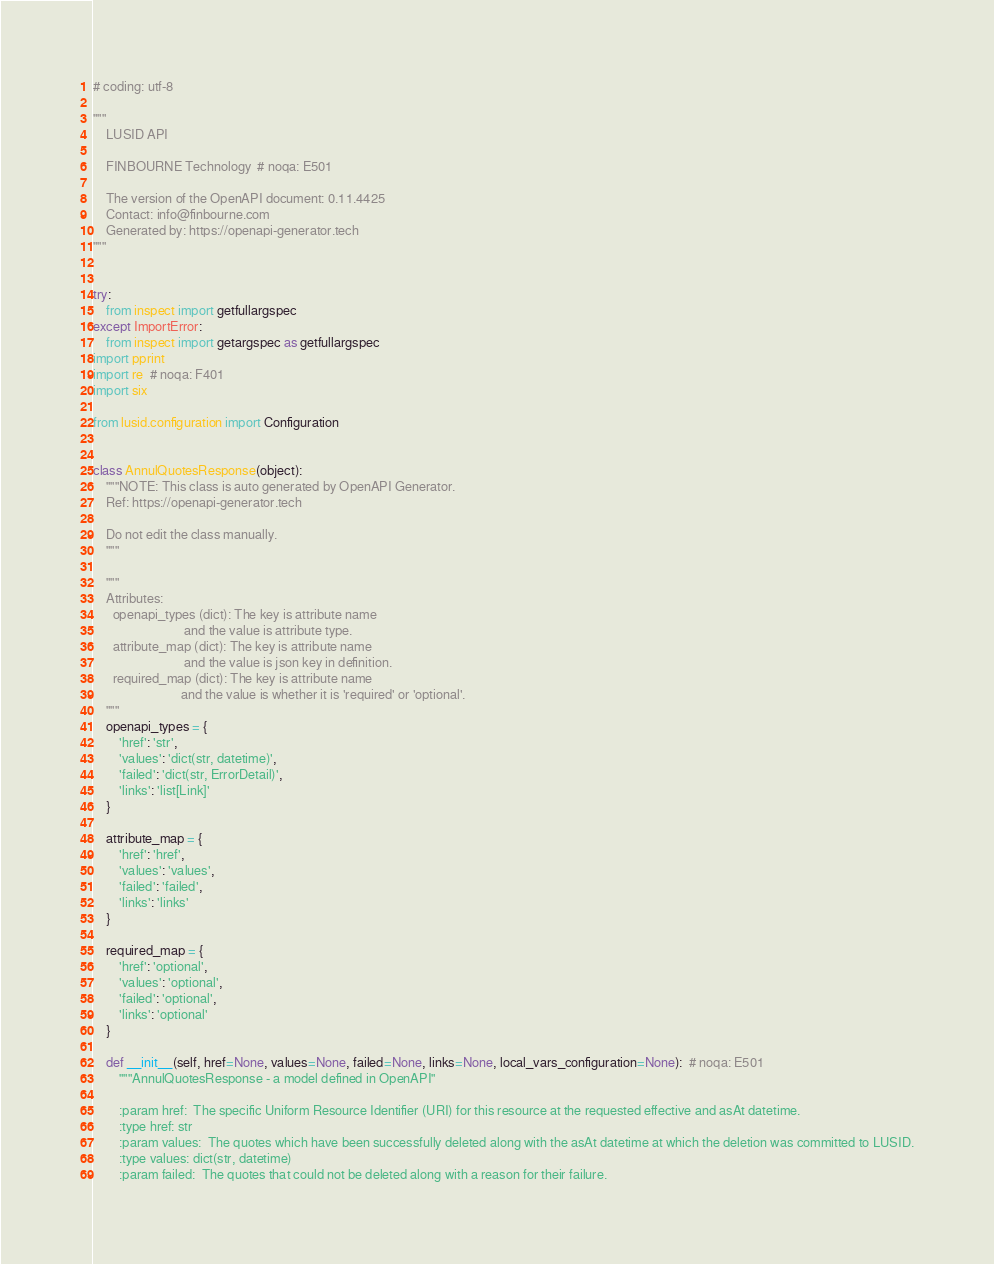Convert code to text. <code><loc_0><loc_0><loc_500><loc_500><_Python_># coding: utf-8

"""
    LUSID API

    FINBOURNE Technology  # noqa: E501

    The version of the OpenAPI document: 0.11.4425
    Contact: info@finbourne.com
    Generated by: https://openapi-generator.tech
"""


try:
    from inspect import getfullargspec
except ImportError:
    from inspect import getargspec as getfullargspec
import pprint
import re  # noqa: F401
import six

from lusid.configuration import Configuration


class AnnulQuotesResponse(object):
    """NOTE: This class is auto generated by OpenAPI Generator.
    Ref: https://openapi-generator.tech

    Do not edit the class manually.
    """

    """
    Attributes:
      openapi_types (dict): The key is attribute name
                            and the value is attribute type.
      attribute_map (dict): The key is attribute name
                            and the value is json key in definition.
      required_map (dict): The key is attribute name
                           and the value is whether it is 'required' or 'optional'.
    """
    openapi_types = {
        'href': 'str',
        'values': 'dict(str, datetime)',
        'failed': 'dict(str, ErrorDetail)',
        'links': 'list[Link]'
    }

    attribute_map = {
        'href': 'href',
        'values': 'values',
        'failed': 'failed',
        'links': 'links'
    }

    required_map = {
        'href': 'optional',
        'values': 'optional',
        'failed': 'optional',
        'links': 'optional'
    }

    def __init__(self, href=None, values=None, failed=None, links=None, local_vars_configuration=None):  # noqa: E501
        """AnnulQuotesResponse - a model defined in OpenAPI"
        
        :param href:  The specific Uniform Resource Identifier (URI) for this resource at the requested effective and asAt datetime.
        :type href: str
        :param values:  The quotes which have been successfully deleted along with the asAt datetime at which the deletion was committed to LUSID.
        :type values: dict(str, datetime)
        :param failed:  The quotes that could not be deleted along with a reason for their failure.</code> 